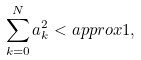Convert formula to latex. <formula><loc_0><loc_0><loc_500><loc_500>\sum _ { k = 0 } ^ { N } a _ { k } ^ { 2 } < a p p r o x 1 ,</formula> 